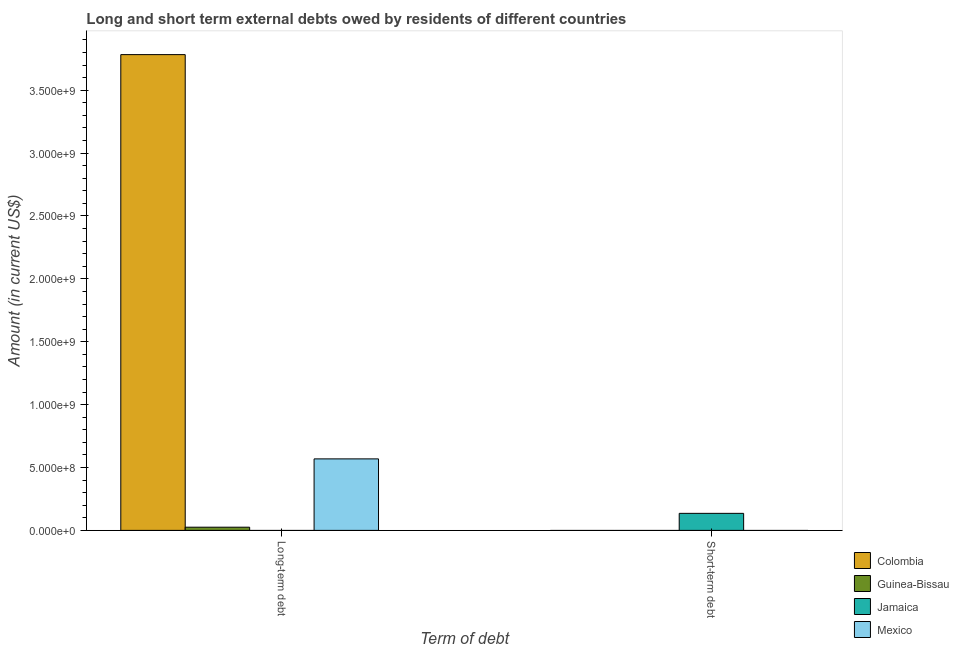How many different coloured bars are there?
Offer a terse response. 4. Are the number of bars per tick equal to the number of legend labels?
Make the answer very short. No. What is the label of the 1st group of bars from the left?
Make the answer very short. Long-term debt. What is the long-term debts owed by residents in Mexico?
Your answer should be very brief. 5.69e+08. Across all countries, what is the maximum short-term debts owed by residents?
Your response must be concise. 1.35e+08. What is the total long-term debts owed by residents in the graph?
Offer a terse response. 4.38e+09. What is the difference between the long-term debts owed by residents in Mexico and that in Guinea-Bissau?
Offer a very short reply. 5.43e+08. What is the average long-term debts owed by residents per country?
Provide a succinct answer. 1.09e+09. In how many countries, is the short-term debts owed by residents greater than 3400000000 US$?
Offer a very short reply. 0. What is the ratio of the long-term debts owed by residents in Colombia to that in Guinea-Bissau?
Provide a short and direct response. 149.42. Is the long-term debts owed by residents in Guinea-Bissau less than that in Mexico?
Provide a succinct answer. Yes. Are all the bars in the graph horizontal?
Keep it short and to the point. No. Are the values on the major ticks of Y-axis written in scientific E-notation?
Keep it short and to the point. Yes. Where does the legend appear in the graph?
Offer a terse response. Bottom right. How many legend labels are there?
Make the answer very short. 4. How are the legend labels stacked?
Offer a very short reply. Vertical. What is the title of the graph?
Offer a terse response. Long and short term external debts owed by residents of different countries. What is the label or title of the X-axis?
Provide a succinct answer. Term of debt. What is the Amount (in current US$) in Colombia in Long-term debt?
Offer a terse response. 3.78e+09. What is the Amount (in current US$) of Guinea-Bissau in Long-term debt?
Offer a very short reply. 2.53e+07. What is the Amount (in current US$) in Jamaica in Long-term debt?
Offer a very short reply. 0. What is the Amount (in current US$) in Mexico in Long-term debt?
Your answer should be compact. 5.69e+08. What is the Amount (in current US$) in Colombia in Short-term debt?
Make the answer very short. 0. What is the Amount (in current US$) in Jamaica in Short-term debt?
Give a very brief answer. 1.35e+08. Across all Term of debt, what is the maximum Amount (in current US$) of Colombia?
Your answer should be very brief. 3.78e+09. Across all Term of debt, what is the maximum Amount (in current US$) of Guinea-Bissau?
Provide a succinct answer. 2.53e+07. Across all Term of debt, what is the maximum Amount (in current US$) of Jamaica?
Give a very brief answer. 1.35e+08. Across all Term of debt, what is the maximum Amount (in current US$) in Mexico?
Your answer should be compact. 5.69e+08. Across all Term of debt, what is the minimum Amount (in current US$) in Colombia?
Keep it short and to the point. 0. Across all Term of debt, what is the minimum Amount (in current US$) in Guinea-Bissau?
Make the answer very short. 0. Across all Term of debt, what is the minimum Amount (in current US$) of Jamaica?
Ensure brevity in your answer.  0. What is the total Amount (in current US$) in Colombia in the graph?
Offer a terse response. 3.78e+09. What is the total Amount (in current US$) of Guinea-Bissau in the graph?
Provide a succinct answer. 2.53e+07. What is the total Amount (in current US$) of Jamaica in the graph?
Your response must be concise. 1.35e+08. What is the total Amount (in current US$) in Mexico in the graph?
Your response must be concise. 5.69e+08. What is the difference between the Amount (in current US$) in Colombia in Long-term debt and the Amount (in current US$) in Jamaica in Short-term debt?
Make the answer very short. 3.65e+09. What is the difference between the Amount (in current US$) of Guinea-Bissau in Long-term debt and the Amount (in current US$) of Jamaica in Short-term debt?
Keep it short and to the point. -1.10e+08. What is the average Amount (in current US$) in Colombia per Term of debt?
Provide a short and direct response. 1.89e+09. What is the average Amount (in current US$) in Guinea-Bissau per Term of debt?
Offer a very short reply. 1.27e+07. What is the average Amount (in current US$) of Jamaica per Term of debt?
Give a very brief answer. 6.77e+07. What is the average Amount (in current US$) of Mexico per Term of debt?
Keep it short and to the point. 2.84e+08. What is the difference between the Amount (in current US$) of Colombia and Amount (in current US$) of Guinea-Bissau in Long-term debt?
Ensure brevity in your answer.  3.76e+09. What is the difference between the Amount (in current US$) of Colombia and Amount (in current US$) of Mexico in Long-term debt?
Provide a succinct answer. 3.21e+09. What is the difference between the Amount (in current US$) in Guinea-Bissau and Amount (in current US$) in Mexico in Long-term debt?
Make the answer very short. -5.43e+08. What is the difference between the highest and the lowest Amount (in current US$) in Colombia?
Provide a short and direct response. 3.78e+09. What is the difference between the highest and the lowest Amount (in current US$) of Guinea-Bissau?
Ensure brevity in your answer.  2.53e+07. What is the difference between the highest and the lowest Amount (in current US$) in Jamaica?
Provide a short and direct response. 1.35e+08. What is the difference between the highest and the lowest Amount (in current US$) of Mexico?
Make the answer very short. 5.69e+08. 